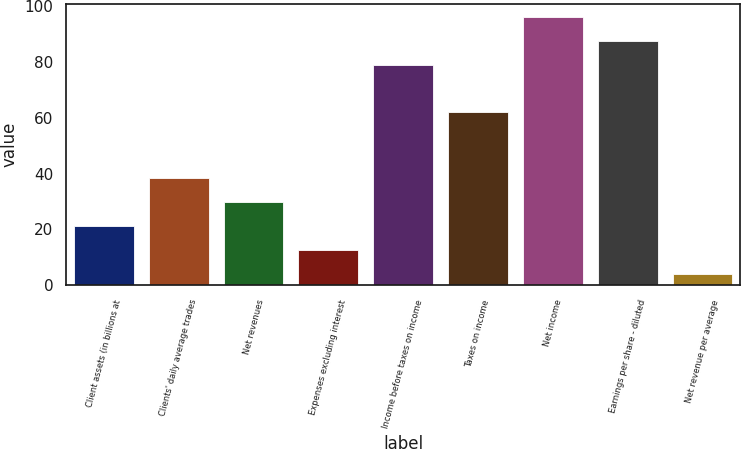Convert chart to OTSL. <chart><loc_0><loc_0><loc_500><loc_500><bar_chart><fcel>Client assets (in billions at<fcel>Clients' daily average trades<fcel>Net revenues<fcel>Expenses excluding interest<fcel>Income before taxes on income<fcel>Taxes on income<fcel>Net income<fcel>Earnings per share - diluted<fcel>Net revenue per average<nl><fcel>21.2<fcel>38.4<fcel>29.8<fcel>12.6<fcel>79<fcel>62<fcel>96.2<fcel>87.6<fcel>4<nl></chart> 